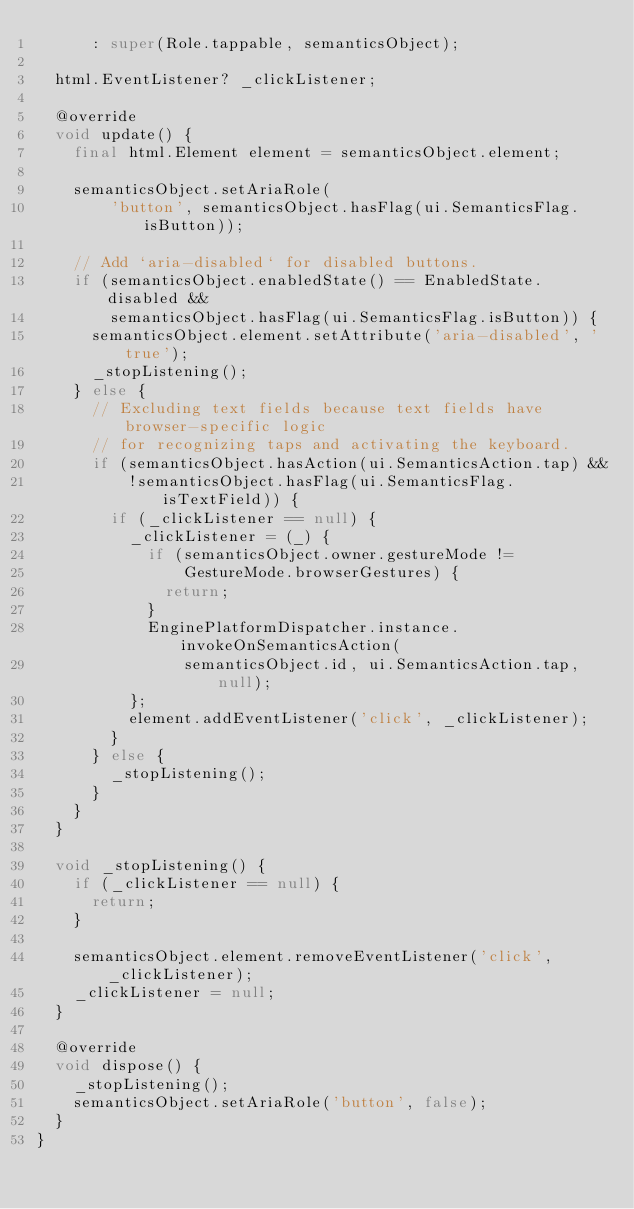Convert code to text. <code><loc_0><loc_0><loc_500><loc_500><_Dart_>      : super(Role.tappable, semanticsObject);

  html.EventListener? _clickListener;

  @override
  void update() {
    final html.Element element = semanticsObject.element;

    semanticsObject.setAriaRole(
        'button', semanticsObject.hasFlag(ui.SemanticsFlag.isButton));

    // Add `aria-disabled` for disabled buttons.
    if (semanticsObject.enabledState() == EnabledState.disabled &&
        semanticsObject.hasFlag(ui.SemanticsFlag.isButton)) {
      semanticsObject.element.setAttribute('aria-disabled', 'true');
      _stopListening();
    } else {
      // Excluding text fields because text fields have browser-specific logic
      // for recognizing taps and activating the keyboard.
      if (semanticsObject.hasAction(ui.SemanticsAction.tap) &&
          !semanticsObject.hasFlag(ui.SemanticsFlag.isTextField)) {
        if (_clickListener == null) {
          _clickListener = (_) {
            if (semanticsObject.owner.gestureMode !=
                GestureMode.browserGestures) {
              return;
            }
            EnginePlatformDispatcher.instance.invokeOnSemanticsAction(
                semanticsObject.id, ui.SemanticsAction.tap, null);
          };
          element.addEventListener('click', _clickListener);
        }
      } else {
        _stopListening();
      }
    }
  }

  void _stopListening() {
    if (_clickListener == null) {
      return;
    }

    semanticsObject.element.removeEventListener('click', _clickListener);
    _clickListener = null;
  }

  @override
  void dispose() {
    _stopListening();
    semanticsObject.setAriaRole('button', false);
  }
}
</code> 